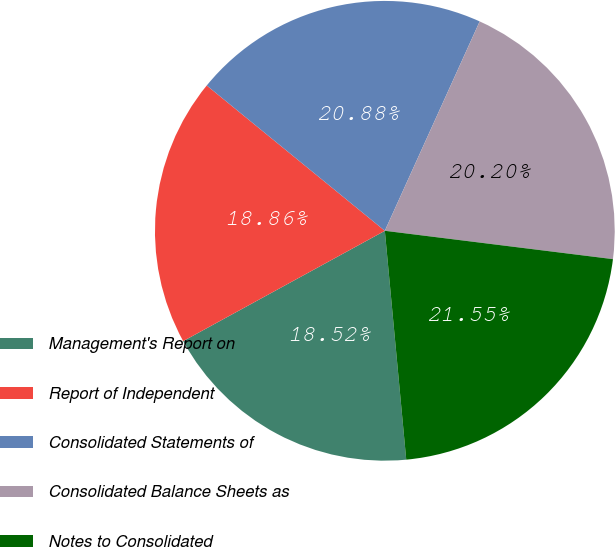<chart> <loc_0><loc_0><loc_500><loc_500><pie_chart><fcel>Management's Report on<fcel>Report of Independent<fcel>Consolidated Statements of<fcel>Consolidated Balance Sheets as<fcel>Notes to Consolidated<nl><fcel>18.52%<fcel>18.86%<fcel>20.88%<fcel>20.2%<fcel>21.55%<nl></chart> 